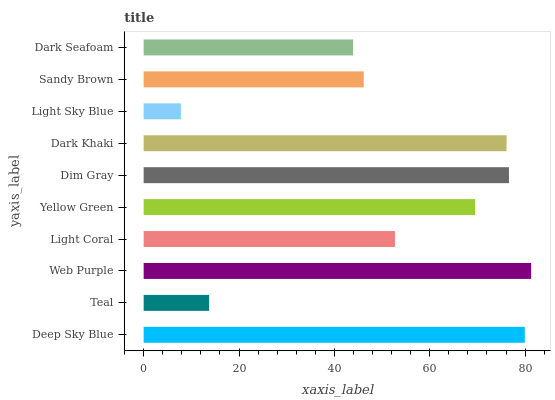Is Light Sky Blue the minimum?
Answer yes or no. Yes. Is Web Purple the maximum?
Answer yes or no. Yes. Is Teal the minimum?
Answer yes or no. No. Is Teal the maximum?
Answer yes or no. No. Is Deep Sky Blue greater than Teal?
Answer yes or no. Yes. Is Teal less than Deep Sky Blue?
Answer yes or no. Yes. Is Teal greater than Deep Sky Blue?
Answer yes or no. No. Is Deep Sky Blue less than Teal?
Answer yes or no. No. Is Yellow Green the high median?
Answer yes or no. Yes. Is Light Coral the low median?
Answer yes or no. Yes. Is Dim Gray the high median?
Answer yes or no. No. Is Teal the low median?
Answer yes or no. No. 